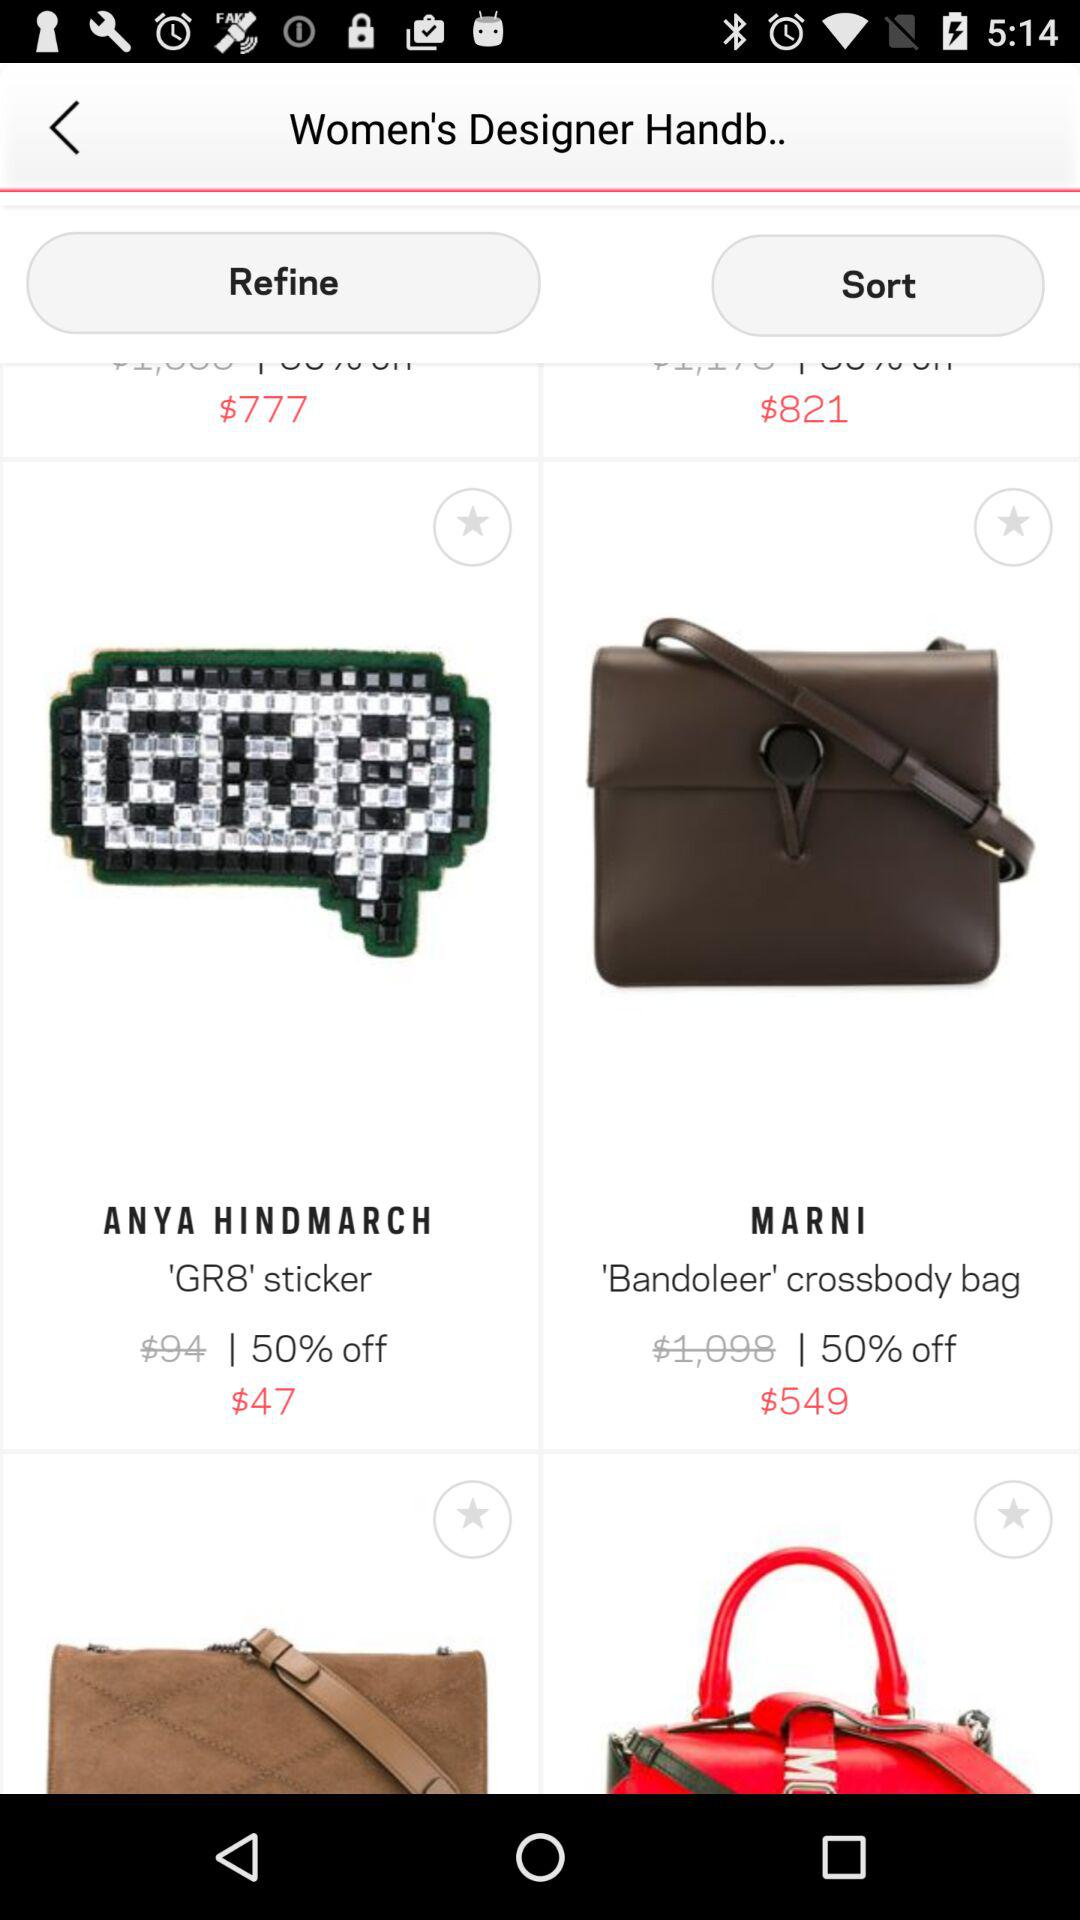Which item has a lower price, the Minecraft block bag or the Bandoleer crossbody bag?
Answer the question using a single word or phrase. Minecraft block bag 